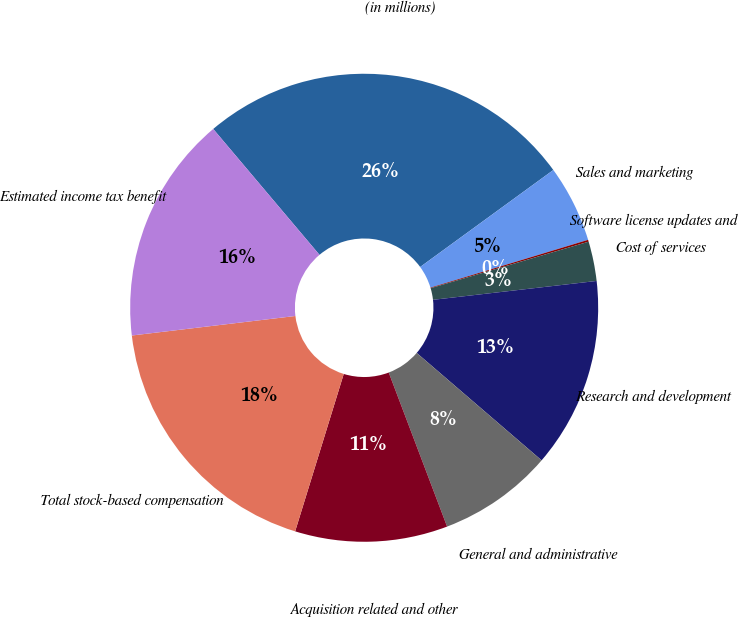Convert chart to OTSL. <chart><loc_0><loc_0><loc_500><loc_500><pie_chart><fcel>(in millions)<fcel>Sales and marketing<fcel>Software license updates and<fcel>Cost of services<fcel>Research and development<fcel>General and administrative<fcel>Acquisition related and other<fcel>Total stock-based compensation<fcel>Estimated income tax benefit<nl><fcel>26.14%<fcel>5.33%<fcel>0.13%<fcel>2.73%<fcel>13.13%<fcel>7.93%<fcel>10.53%<fcel>18.34%<fcel>15.73%<nl></chart> 